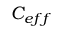Convert formula to latex. <formula><loc_0><loc_0><loc_500><loc_500>C _ { e f f }</formula> 